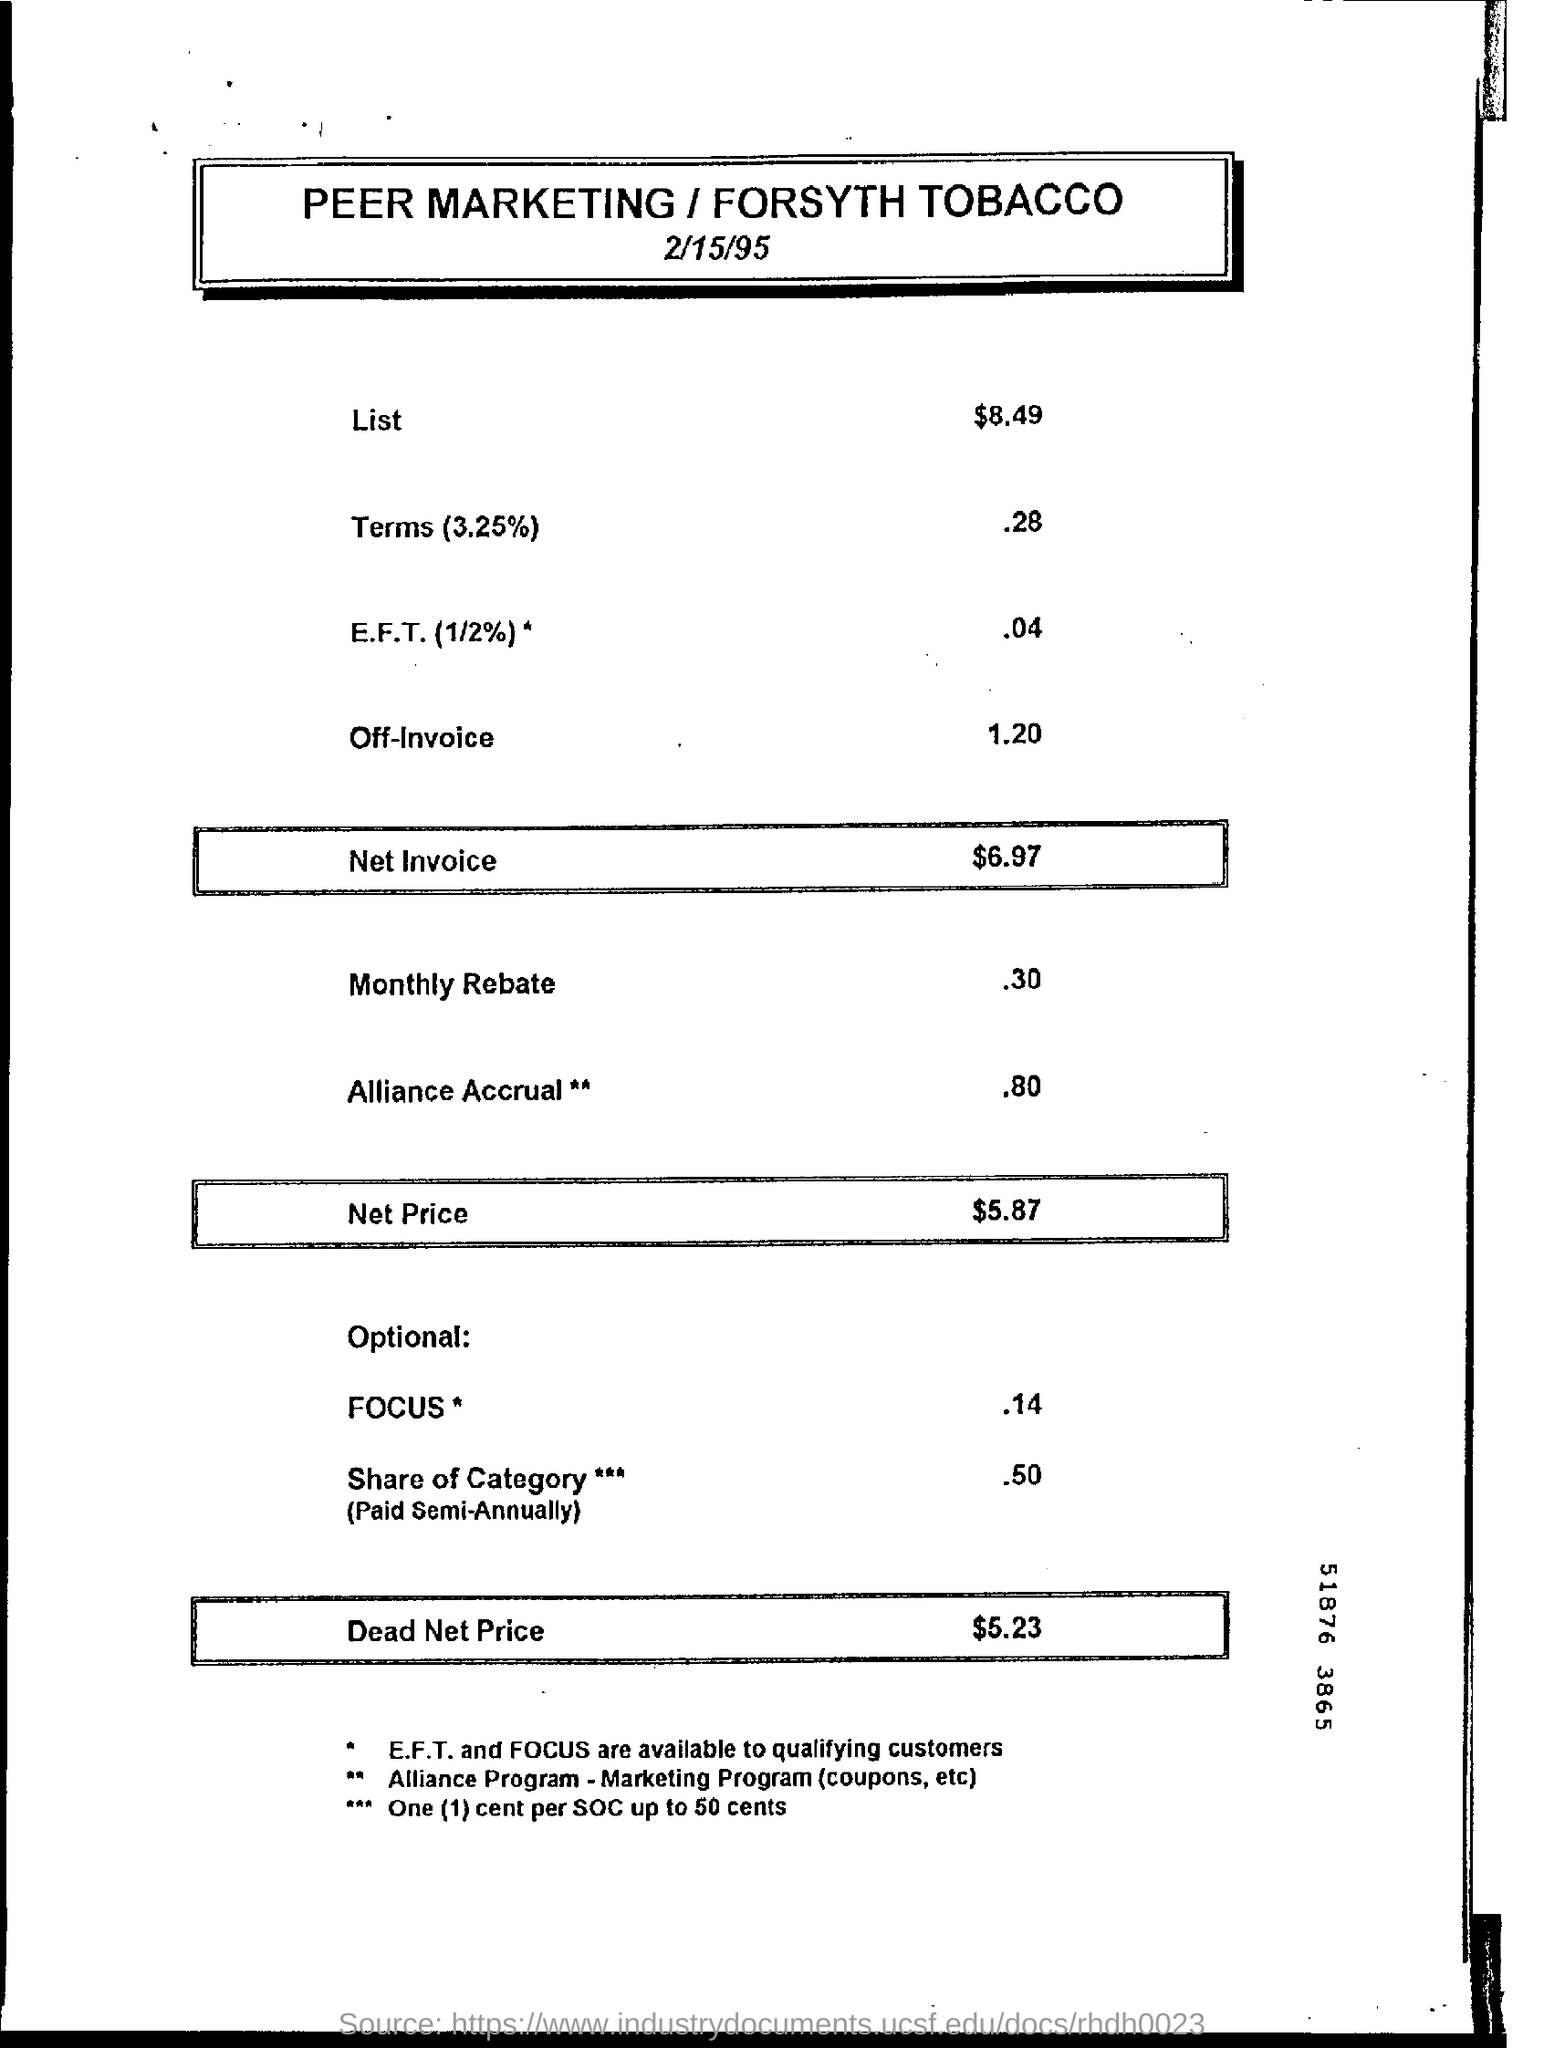Value mentioned in the List category
Provide a succinct answer. $8.49. What is the net invoice value
Give a very brief answer. $6.97. How much is the monthly rebate
Keep it short and to the point. .30. What is the net price
Offer a very short reply. $5.87. What is the dead net price
Offer a very short reply. $5.23. 